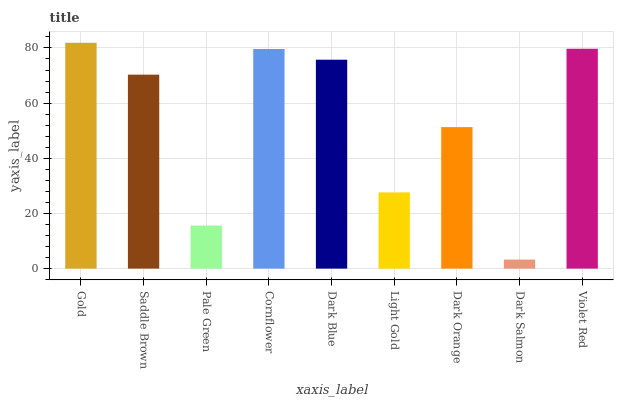Is Dark Salmon the minimum?
Answer yes or no. Yes. Is Gold the maximum?
Answer yes or no. Yes. Is Saddle Brown the minimum?
Answer yes or no. No. Is Saddle Brown the maximum?
Answer yes or no. No. Is Gold greater than Saddle Brown?
Answer yes or no. Yes. Is Saddle Brown less than Gold?
Answer yes or no. Yes. Is Saddle Brown greater than Gold?
Answer yes or no. No. Is Gold less than Saddle Brown?
Answer yes or no. No. Is Saddle Brown the high median?
Answer yes or no. Yes. Is Saddle Brown the low median?
Answer yes or no. Yes. Is Gold the high median?
Answer yes or no. No. Is Dark Blue the low median?
Answer yes or no. No. 